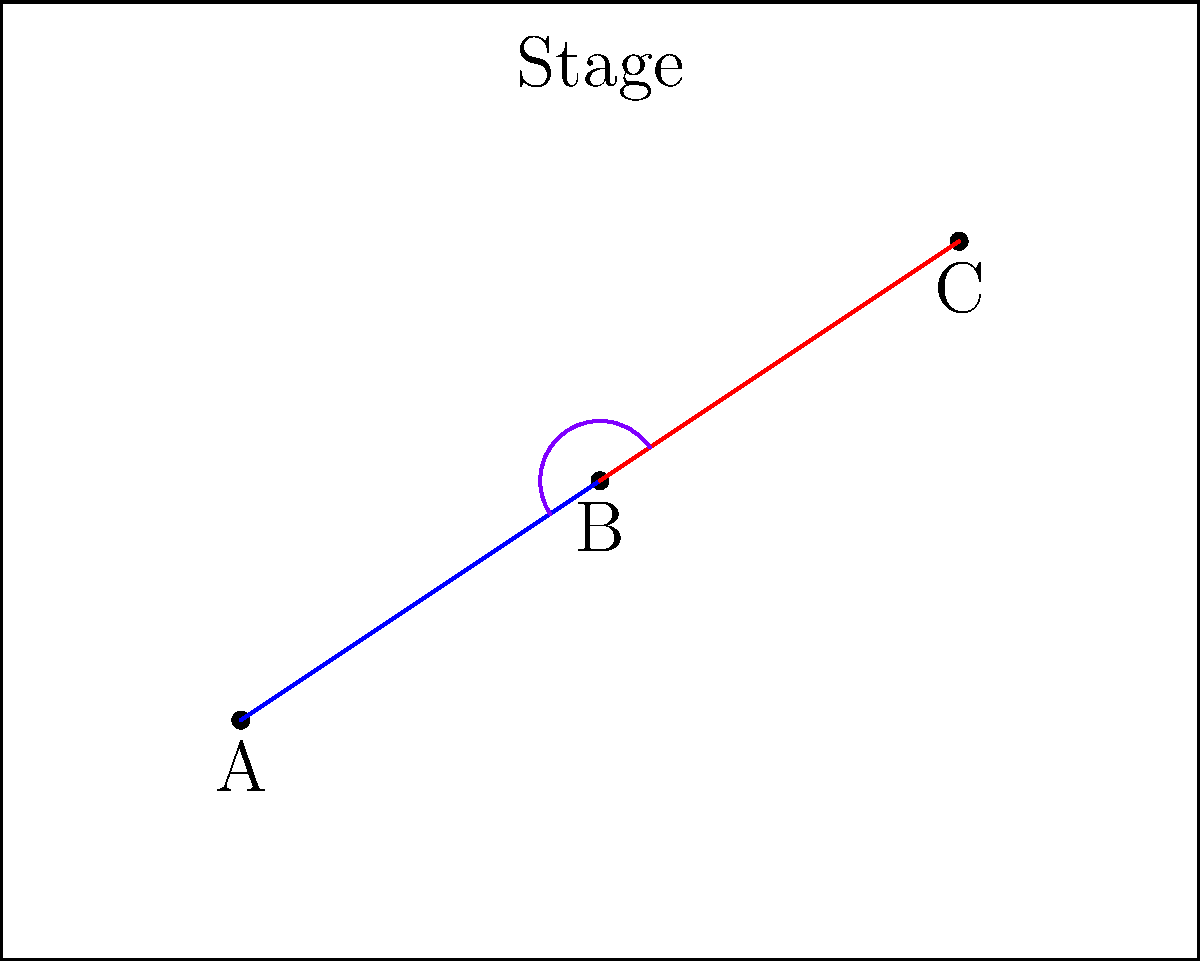In the diagram above, three ballet dancers (A, B, and C) are positioned on stage in an arabesque formation. The blue line represents the distance between dancers A and B, while the red line represents the distance between dancers B and C. If the angle formed at dancer B is 120°, and the distance between A and B is 5 meters, what is the distance between B and C to the nearest meter? To solve this problem, we'll use the law of cosines, which is ideal for triangles where we know two sides and the included angle. Let's approach this step-by-step:

1. We know:
   - The angle at B is 120°
   - The distance AB (blue line) is 5 meters
   - We need to find BC (red line)

2. The law of cosines states:
   $$ c^2 = a^2 + b^2 - 2ab \cos(C) $$
   Where c is the side we're looking for (BC), a and b are the known sides, and C is the known angle.

3. In our case:
   - a = 5 (AB)
   - b = BC (what we're solving for)
   - C = 120°

4. Plugging into the formula:
   $$ BC^2 = 5^2 + BC^2 - 2(5)(BC) \cos(120°) $$

5. Simplify:
   $$ BC^2 = 25 + BC^2 - 10BC(-0.5) $$
   Note: $\cos(120°) = -0.5$

6. Further simplify:
   $$ BC^2 = 25 + BC^2 + 5BC $$

7. Subtract $BC^2$ from both sides:
   $$ 0 = 25 + 5BC $$

8. Subtract 25 from both sides:
   $$ -25 = 5BC $$

9. Divide both sides by 5:
   $$ -5 = BC $$

10. Take the absolute value (distance can't be negative):
    $$ BC = 5 $$

Therefore, the distance between dancers B and C is 5 meters.
Answer: 5 meters 